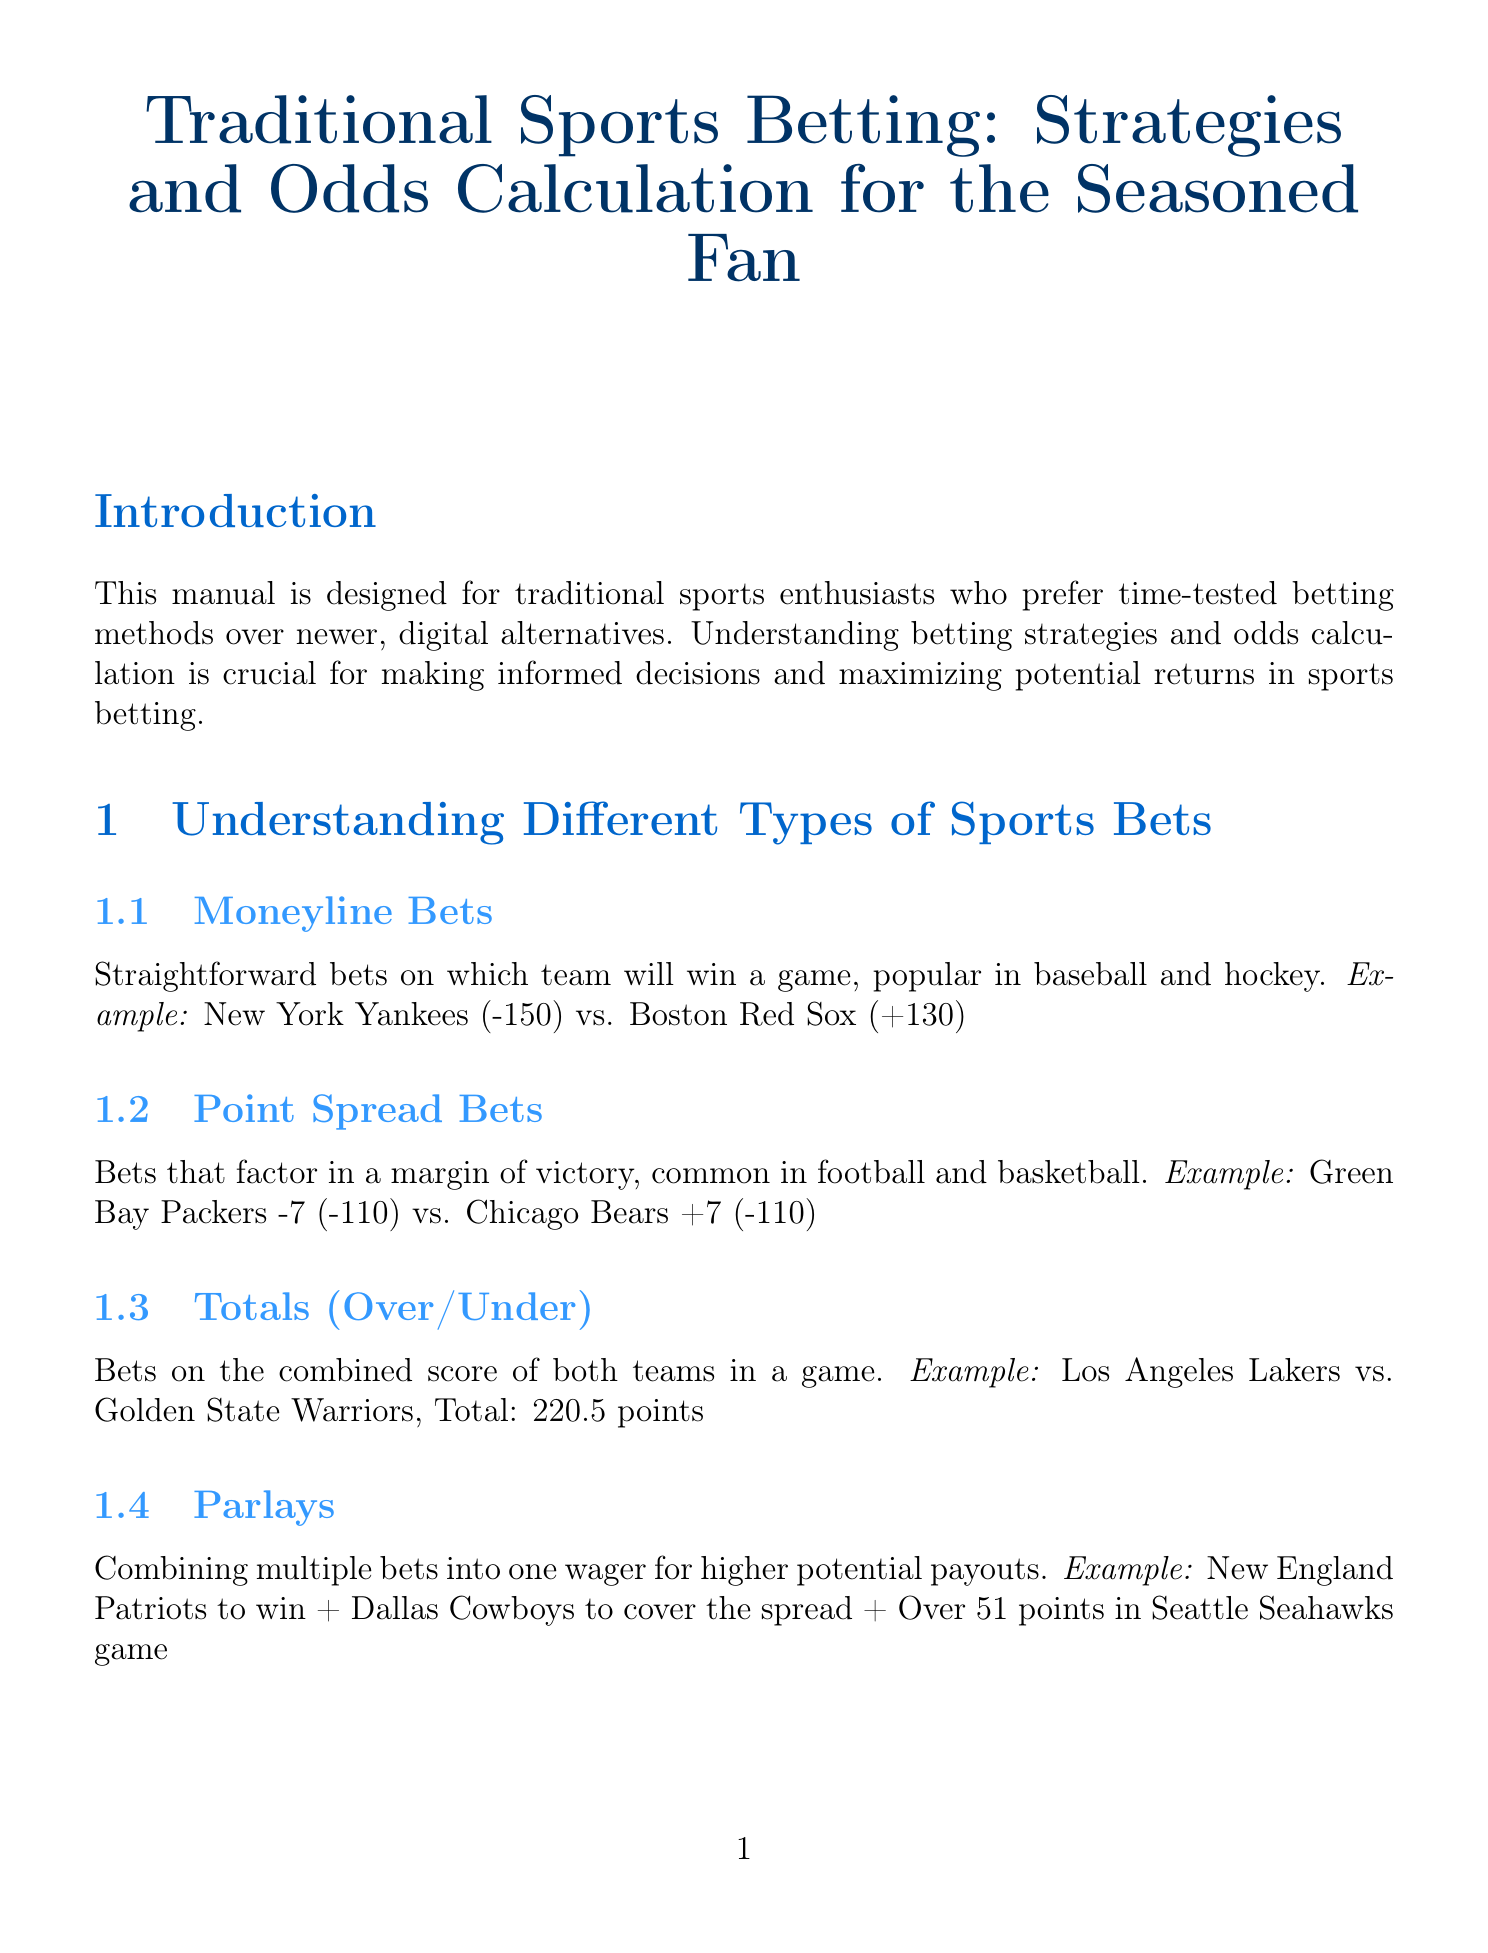What are moneyline bets? Moneyline bets are straightforward bets on which team will win a game, popular in baseball and hockey.
Answer: Straightforward bets on which team will win a game What does the term "vig" refer to? Vig refers to the bookmaker's commission on bets.
Answer: Bookmaker's commission What is an example of a situational betting strategy? The document provides examples to illustrate each strategy, situational betting considers factors like injuries, weather, or team motivation.
Answer: Betting on the 'under' in windy conditions for an NFL game What type of bet combines multiple bets into one wager? Different types of bets are described, and parlays are defined as combining multiple bets into one wager.
Answer: Parlays In NFL betting, what point margins are considered key? The document specifies important margins in NFL betting.
Answer: 3 and 7 point margins What are the recommended sources for staying informed in sports betting? There are various resources mentioned for bettors, focusing on reputable news sources.
Answer: ESPN, The Athletic, and local beat reporters How should you approach bankroll management according to the manual? Proper management strategies are described, emphasizing the percentage of funds to wager.
Answer: Never betting more than 5% of your total bankroll What is the implied probability for odds of -150? Implied probability calculations are included in the document, specifying the percentage based on given odds.
Answer: 60% probability 